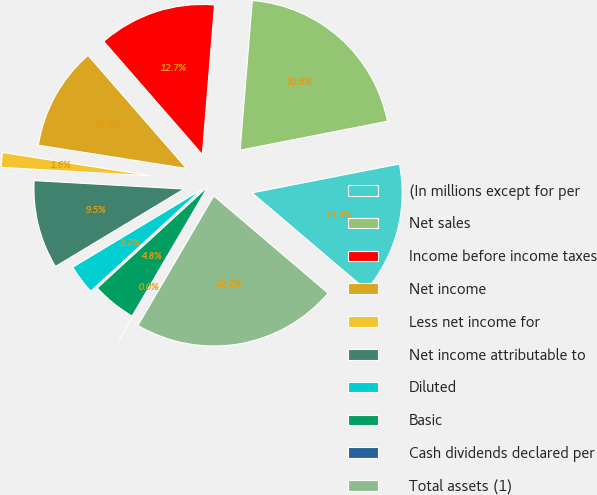Convert chart. <chart><loc_0><loc_0><loc_500><loc_500><pie_chart><fcel>(In millions except for per<fcel>Net sales<fcel>Income before income taxes<fcel>Net income<fcel>Less net income for<fcel>Net income attributable to<fcel>Diluted<fcel>Basic<fcel>Cash dividends declared per<fcel>Total assets (1)<nl><fcel>14.29%<fcel>20.63%<fcel>12.7%<fcel>11.11%<fcel>1.59%<fcel>9.52%<fcel>3.18%<fcel>4.76%<fcel>0.0%<fcel>22.22%<nl></chart> 